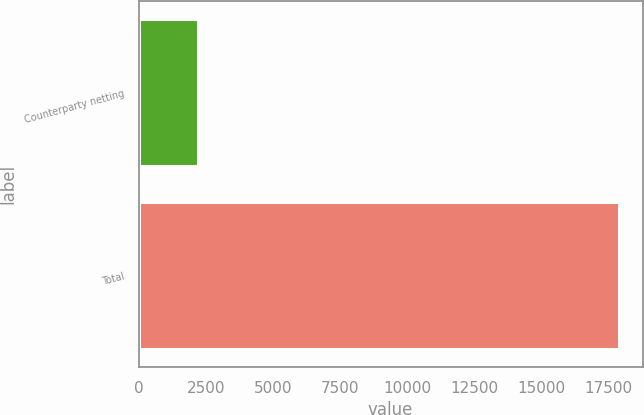Convert chart to OTSL. <chart><loc_0><loc_0><loc_500><loc_500><bar_chart><fcel>Counterparty netting<fcel>Total<nl><fcel>2224<fcel>17881<nl></chart> 